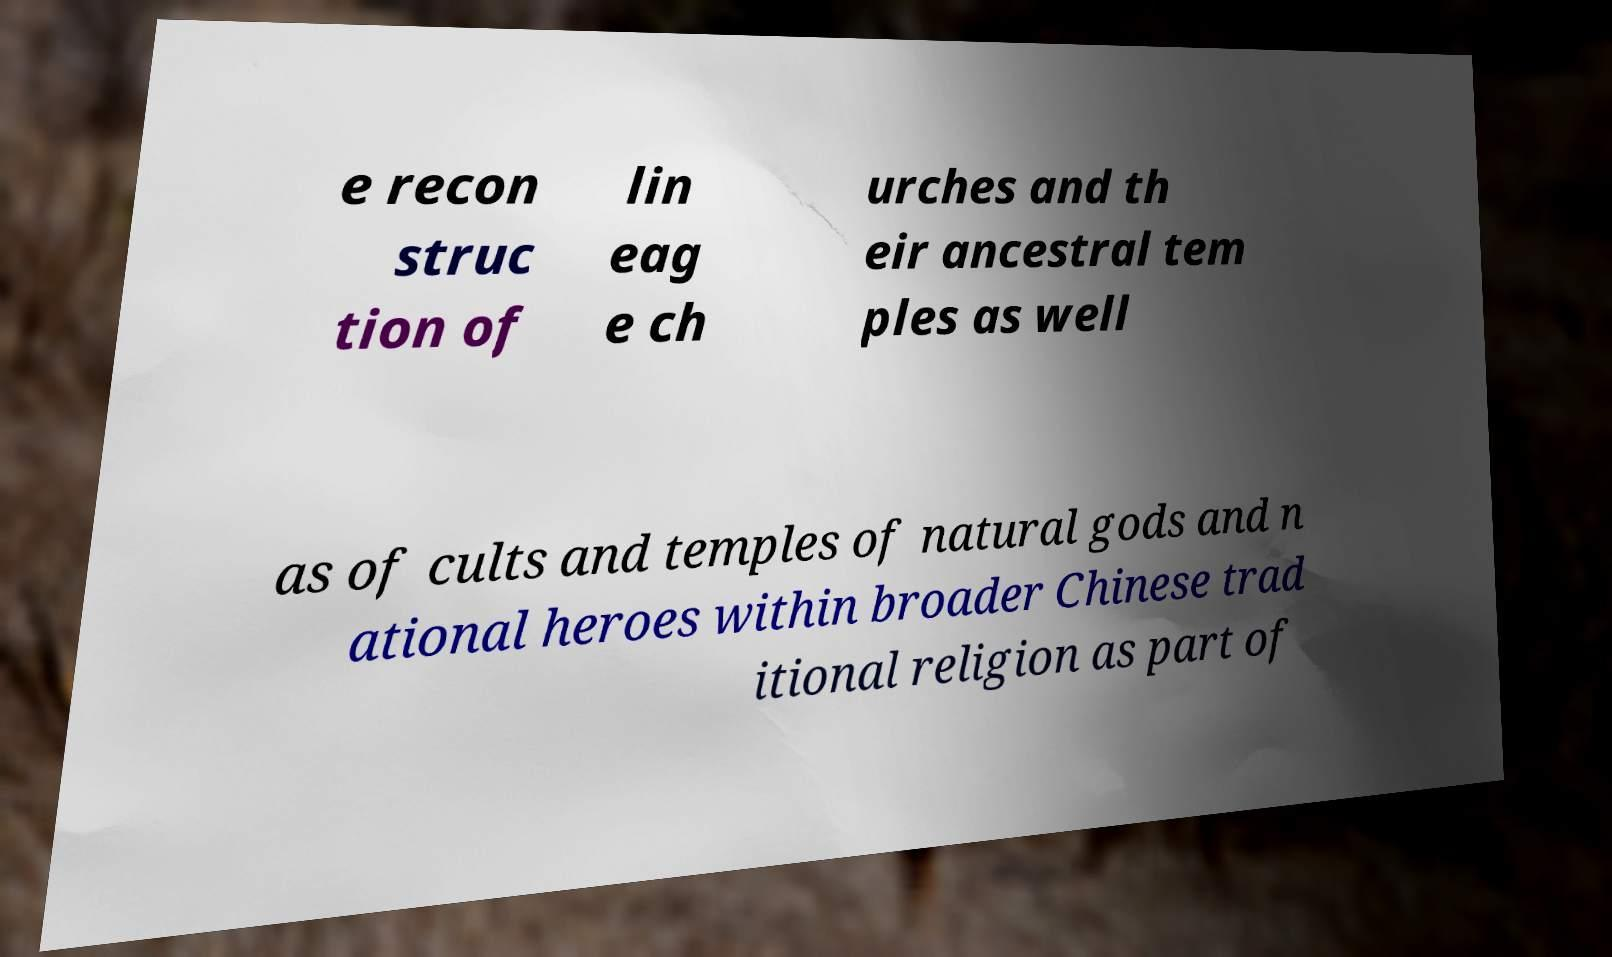Could you extract and type out the text from this image? e recon struc tion of lin eag e ch urches and th eir ancestral tem ples as well as of cults and temples of natural gods and n ational heroes within broader Chinese trad itional religion as part of 